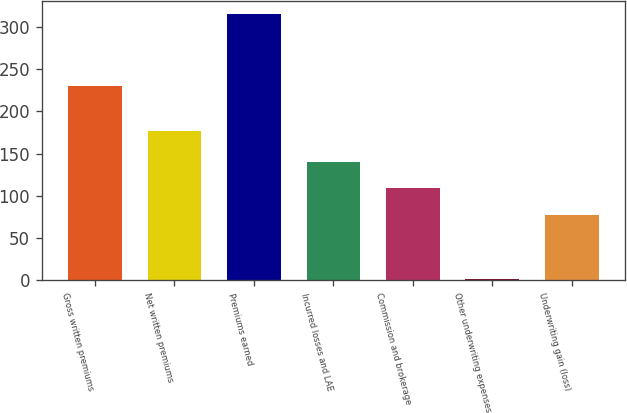Convert chart. <chart><loc_0><loc_0><loc_500><loc_500><bar_chart><fcel>Gross written premiums<fcel>Net written premiums<fcel>Premiums earned<fcel>Incurred losses and LAE<fcel>Commission and brokerage<fcel>Other underwriting expenses<fcel>Underwriting gain (loss)<nl><fcel>229.9<fcel>176.7<fcel>315.3<fcel>140.34<fcel>108.97<fcel>1.6<fcel>77.6<nl></chart> 